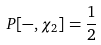Convert formula to latex. <formula><loc_0><loc_0><loc_500><loc_500>P [ - , \chi _ { 2 } ] = \frac { 1 } { 2 }</formula> 